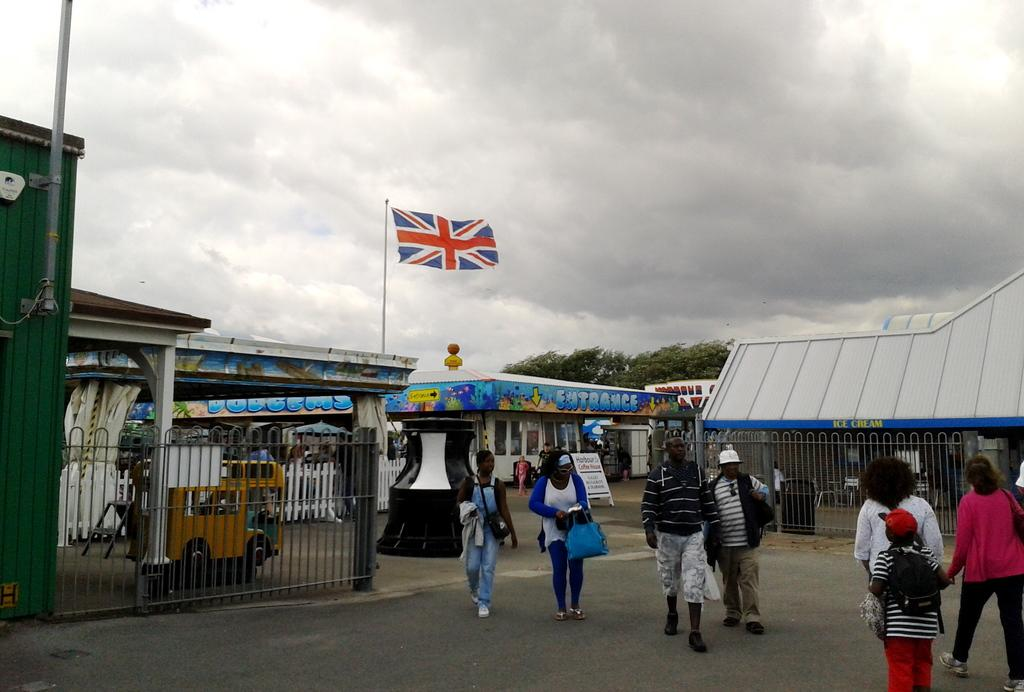Provide a one-sentence caption for the provided image. An entrance sign can be seen on the building near the flag. 